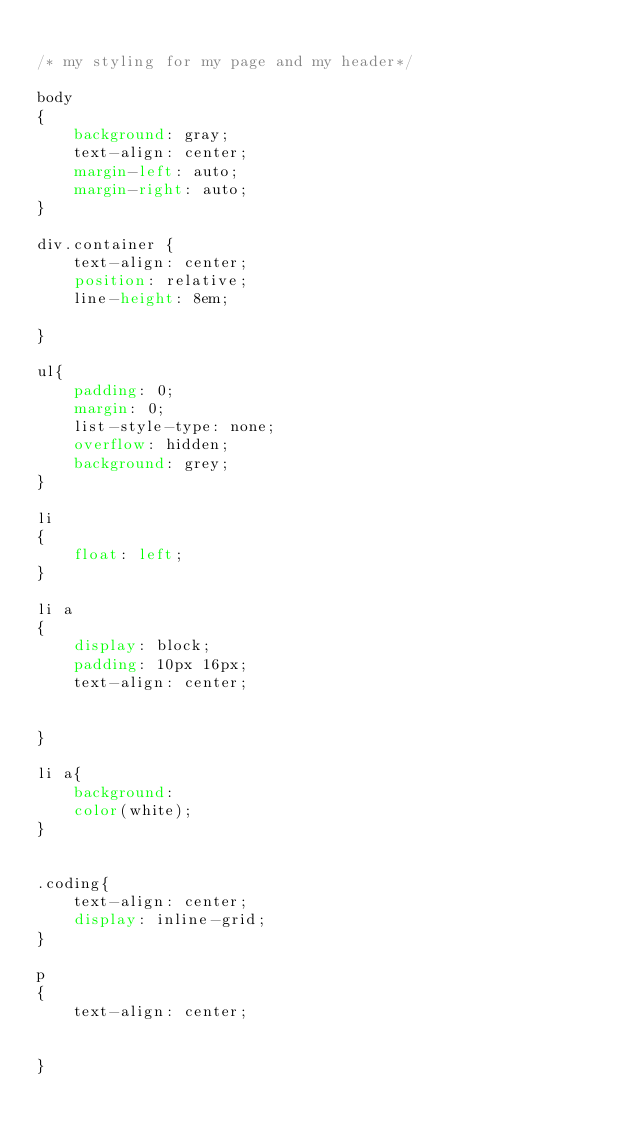Convert code to text. <code><loc_0><loc_0><loc_500><loc_500><_CSS_>
/* my styling for my page and my header*/

body
{
    background: gray;
    text-align: center;
    margin-left: auto;
    margin-right: auto;
}

div.container {
    text-align: center;
    position: relative;
    line-height: 8em;

}

ul{
    padding: 0;
    margin: 0;
    list-style-type: none;
    overflow: hidden;
    background: grey;
}

li
{
    float: left;
}

li a
{
    display: block;
    padding: 10px 16px;
    text-align: center;


}

li a{
    background:
    color(white);
}


.coding{
    text-align: center;
    display: inline-grid;
}

p
{
    text-align: center;


}
</code> 